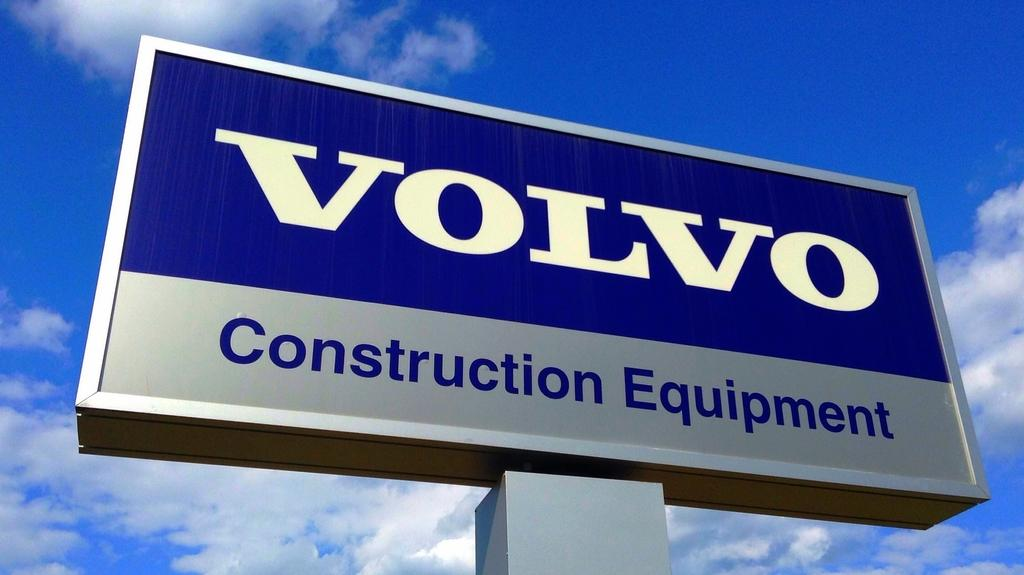<image>
Write a terse but informative summary of the picture. a sign reading volvo construction equipment in front of a blue sky 